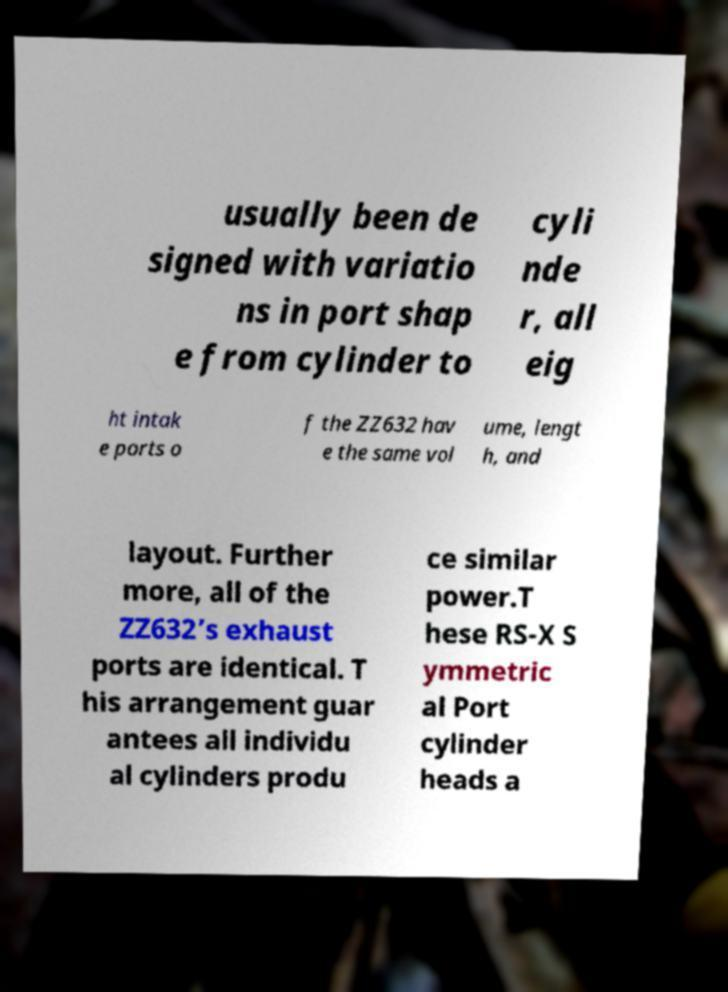I need the written content from this picture converted into text. Can you do that? usually been de signed with variatio ns in port shap e from cylinder to cyli nde r, all eig ht intak e ports o f the ZZ632 hav e the same vol ume, lengt h, and layout. Further more, all of the ZZ632’s exhaust ports are identical. T his arrangement guar antees all individu al cylinders produ ce similar power.T hese RS-X S ymmetric al Port cylinder heads a 